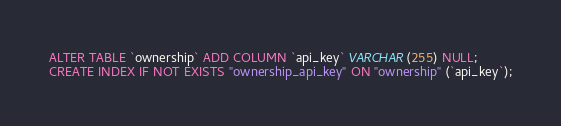Convert code to text. <code><loc_0><loc_0><loc_500><loc_500><_SQL_>ALTER TABLE `ownership` ADD COLUMN `api_key` VARCHAR(255) NULL;
CREATE INDEX IF NOT EXISTS "ownership_api_key" ON "ownership" (`api_key`);</code> 